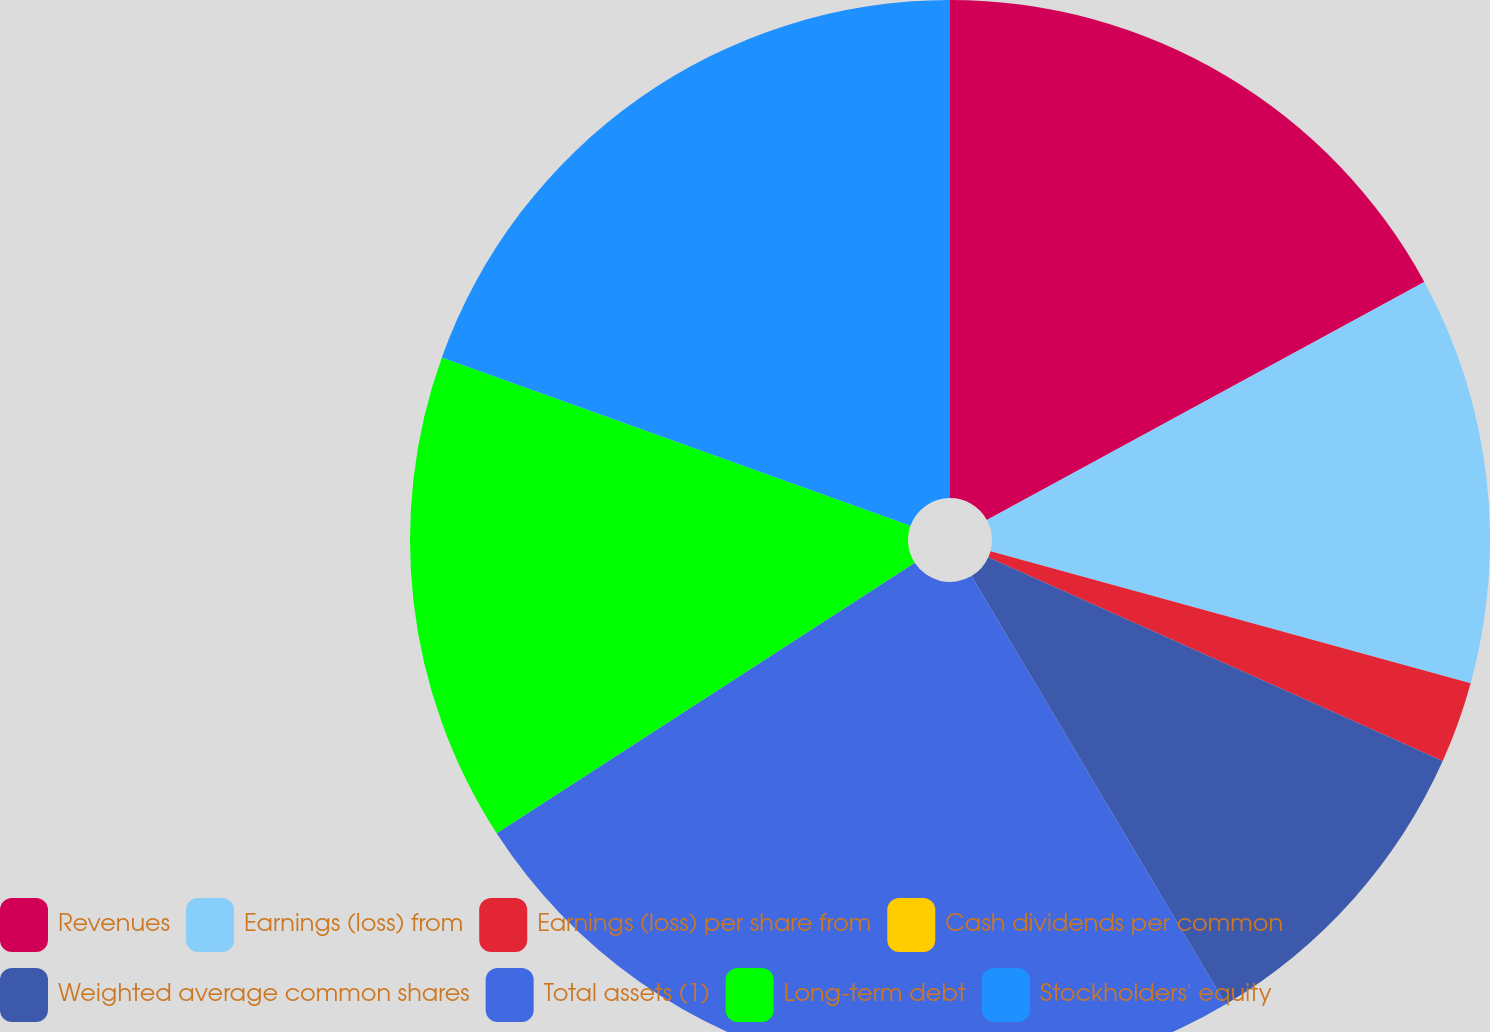Convert chart. <chart><loc_0><loc_0><loc_500><loc_500><pie_chart><fcel>Revenues<fcel>Earnings (loss) from<fcel>Earnings (loss) per share from<fcel>Cash dividends per common<fcel>Weighted average common shares<fcel>Total assets (1)<fcel>Long-term debt<fcel>Stockholders' equity<nl><fcel>17.07%<fcel>12.2%<fcel>2.44%<fcel>0.0%<fcel>9.76%<fcel>24.39%<fcel>14.63%<fcel>19.51%<nl></chart> 